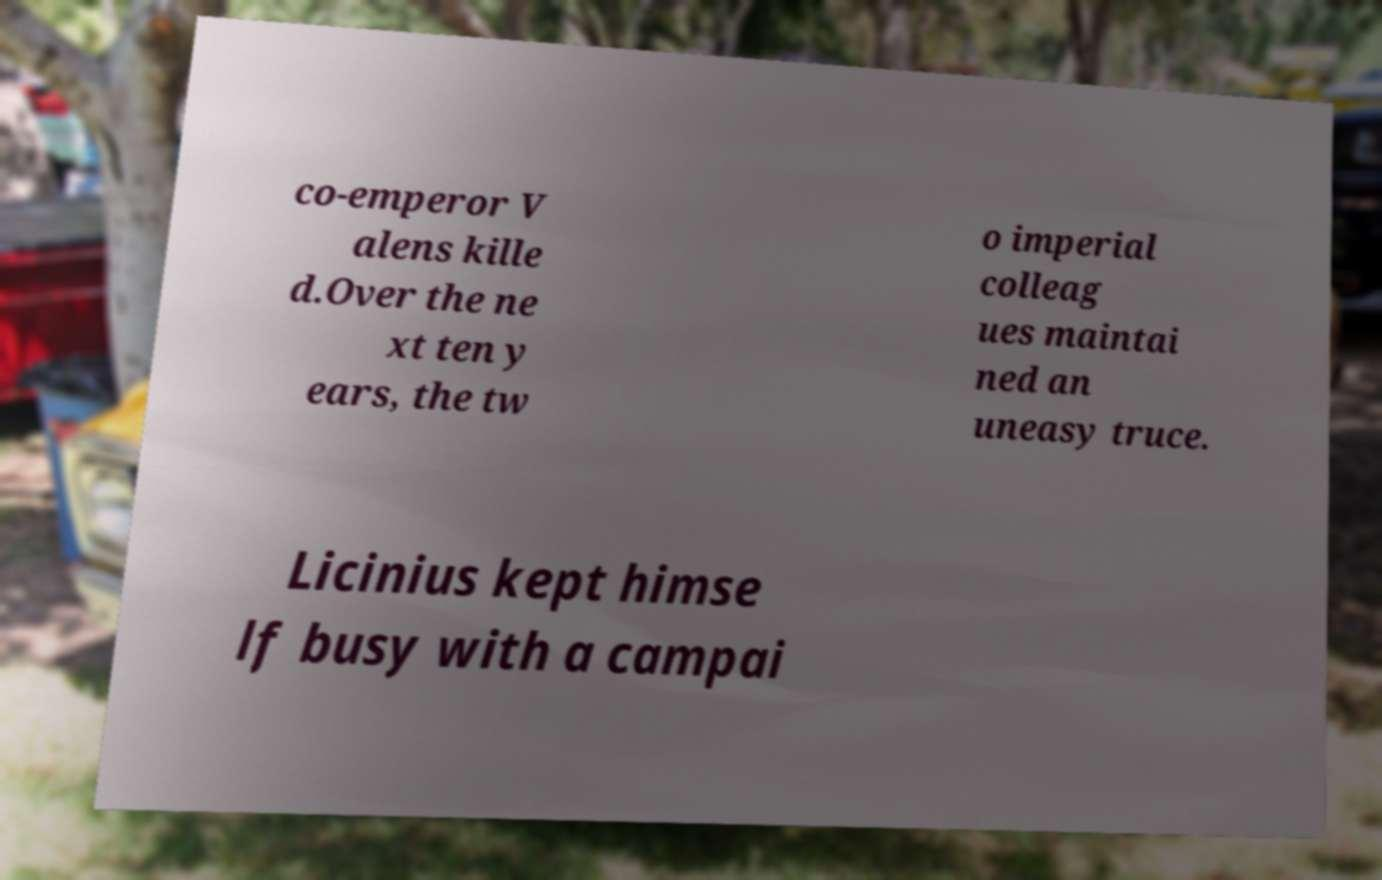Could you extract and type out the text from this image? co-emperor V alens kille d.Over the ne xt ten y ears, the tw o imperial colleag ues maintai ned an uneasy truce. Licinius kept himse lf busy with a campai 